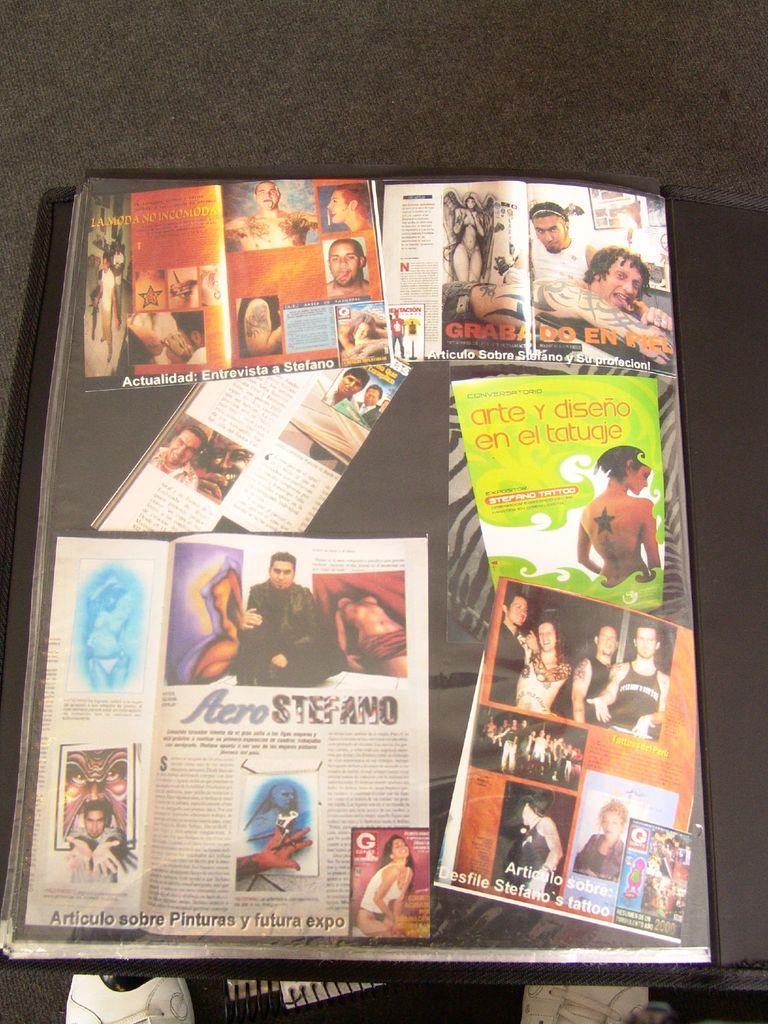Provide a one-sentence caption for the provided image. Magazine covers with one saying "arte y diseno en el tatugie". 